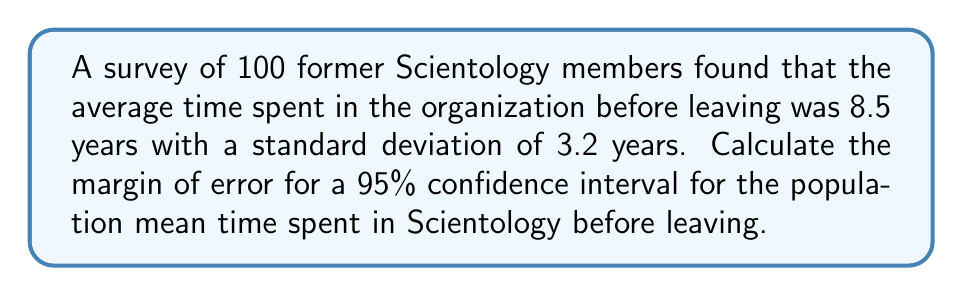Show me your answer to this math problem. To calculate the margin of error for a 95% confidence interval, we'll follow these steps:

1. Identify the critical value:
   For a 95% confidence interval, we use a z-score of 1.96.

2. Recall the formula for margin of error (ME):
   $$ ME = z \cdot \frac{\sigma}{\sqrt{n}} $$
   Where:
   $z$ is the critical value
   $\sigma$ is the population standard deviation
   $n$ is the sample size

3. We don't know the population standard deviation, so we'll use the sample standard deviation as an estimate.

4. Plug in the values:
   $z = 1.96$
   $\sigma \approx s = 3.2$ years
   $n = 100$

5. Calculate:
   $$ ME = 1.96 \cdot \frac{3.2}{\sqrt{100}} = 1.96 \cdot \frac{3.2}{10} = 1.96 \cdot 0.32 = 0.6272 $$

6. Round to two decimal places:
   $ME \approx 0.63$ years
Answer: 0.63 years 